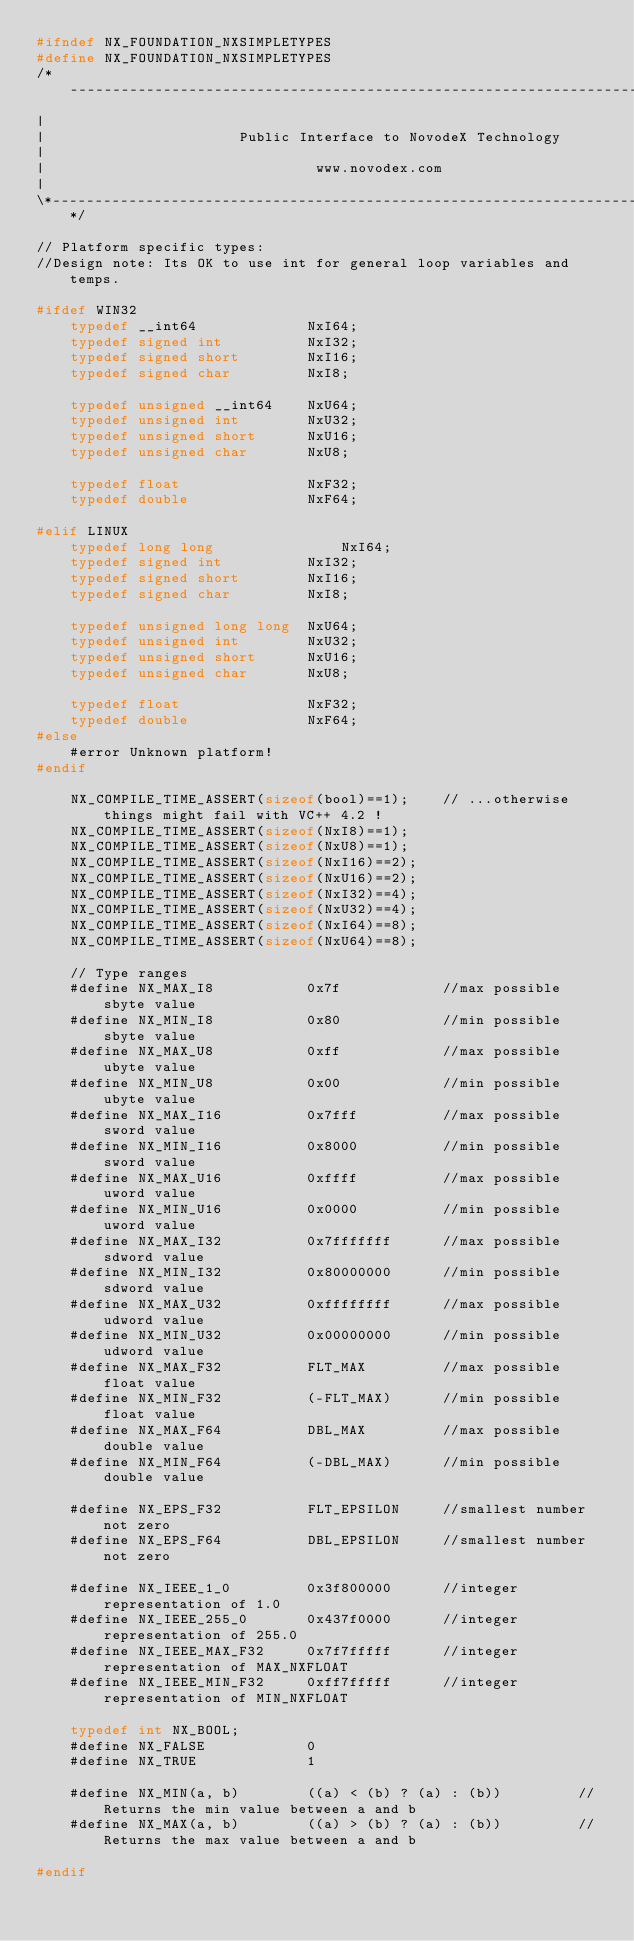Convert code to text. <code><loc_0><loc_0><loc_500><loc_500><_C_>#ifndef NX_FOUNDATION_NXSIMPLETYPES
#define NX_FOUNDATION_NXSIMPLETYPES
/*----------------------------------------------------------------------------*\
|
|						Public Interface to NovodeX Technology
|
|							     www.novodex.com
|
\*----------------------------------------------------------------------------*/

// Platform specific types:
//Design note: Its OK to use int for general loop variables and temps.

#ifdef WIN32
	typedef __int64				NxI64;
	typedef signed int			NxI32;
	typedef signed short		NxI16;
	typedef signed char			NxI8;

	typedef unsigned __int64	NxU64;
	typedef unsigned int		NxU32;
	typedef unsigned short		NxU16;
	typedef unsigned char		NxU8;

	typedef float				NxF32;
	typedef double				NxF64;
		
#elif LINUX
	typedef long long				NxI64;
	typedef signed int			NxI32;
	typedef signed short		NxI16;
	typedef signed char			NxI8;

	typedef unsigned long long	NxU64;
	typedef unsigned int		NxU32;
	typedef unsigned short		NxU16;
	typedef unsigned char		NxU8;

	typedef float				NxF32;
	typedef double				NxF64;
#else
	#error Unknown platform!
#endif

	NX_COMPILE_TIME_ASSERT(sizeof(bool)==1);	// ...otherwise things might fail with VC++ 4.2 !
	NX_COMPILE_TIME_ASSERT(sizeof(NxI8)==1);
	NX_COMPILE_TIME_ASSERT(sizeof(NxU8)==1);
	NX_COMPILE_TIME_ASSERT(sizeof(NxI16)==2);
	NX_COMPILE_TIME_ASSERT(sizeof(NxU16)==2);
	NX_COMPILE_TIME_ASSERT(sizeof(NxI32)==4);
	NX_COMPILE_TIME_ASSERT(sizeof(NxU32)==4);
	NX_COMPILE_TIME_ASSERT(sizeof(NxI64)==8);
	NX_COMPILE_TIME_ASSERT(sizeof(NxU64)==8);

	// Type ranges
	#define	NX_MAX_I8			0x7f			//max possible sbyte value
	#define	NX_MIN_I8			0x80			//min possible sbyte value
	#define	NX_MAX_U8			0xff			//max possible ubyte value
	#define	NX_MIN_U8			0x00			//min possible ubyte value
	#define	NX_MAX_I16			0x7fff			//max possible sword value
	#define	NX_MIN_I16			0x8000			//min possible sword value
	#define	NX_MAX_U16			0xffff			//max possible uword value
	#define	NX_MIN_U16			0x0000			//min possible uword value
	#define	NX_MAX_I32			0x7fffffff		//max possible sdword value
	#define	NX_MIN_I32			0x80000000		//min possible sdword value
	#define	NX_MAX_U32			0xffffffff		//max possible udword value
	#define	NX_MIN_U32			0x00000000		//min possible udword value
	#define	NX_MAX_F32			FLT_MAX			//max possible float value
	#define	NX_MIN_F32			(-FLT_MAX)		//min possible float value
	#define	NX_MAX_F64			DBL_MAX			//max possible double value
	#define	NX_MIN_F64			(-DBL_MAX)		//min possible double value

	#define NX_EPS_F32			FLT_EPSILON		//smallest number not zero
	#define NX_EPS_F64			DBL_EPSILON		//smallest number not zero

	#define NX_IEEE_1_0			0x3f800000		//integer representation of 1.0
	#define NX_IEEE_255_0		0x437f0000		//integer representation of 255.0
	#define NX_IEEE_MAX_F32		0x7f7fffff		//integer representation of MAX_NXFLOAT
	#define NX_IEEE_MIN_F32		0xff7fffff		//integer representation of MIN_NXFLOAT

	typedef int	NX_BOOL;
	#define NX_FALSE			0
	#define NX_TRUE				1

	#define	NX_MIN(a, b)		((a) < (b) ? (a) : (b))			//Returns the min value between a and b
	#define	NX_MAX(a, b)		((a) > (b) ? (a) : (b))			//Returns the max value between a and b

#endif
</code> 